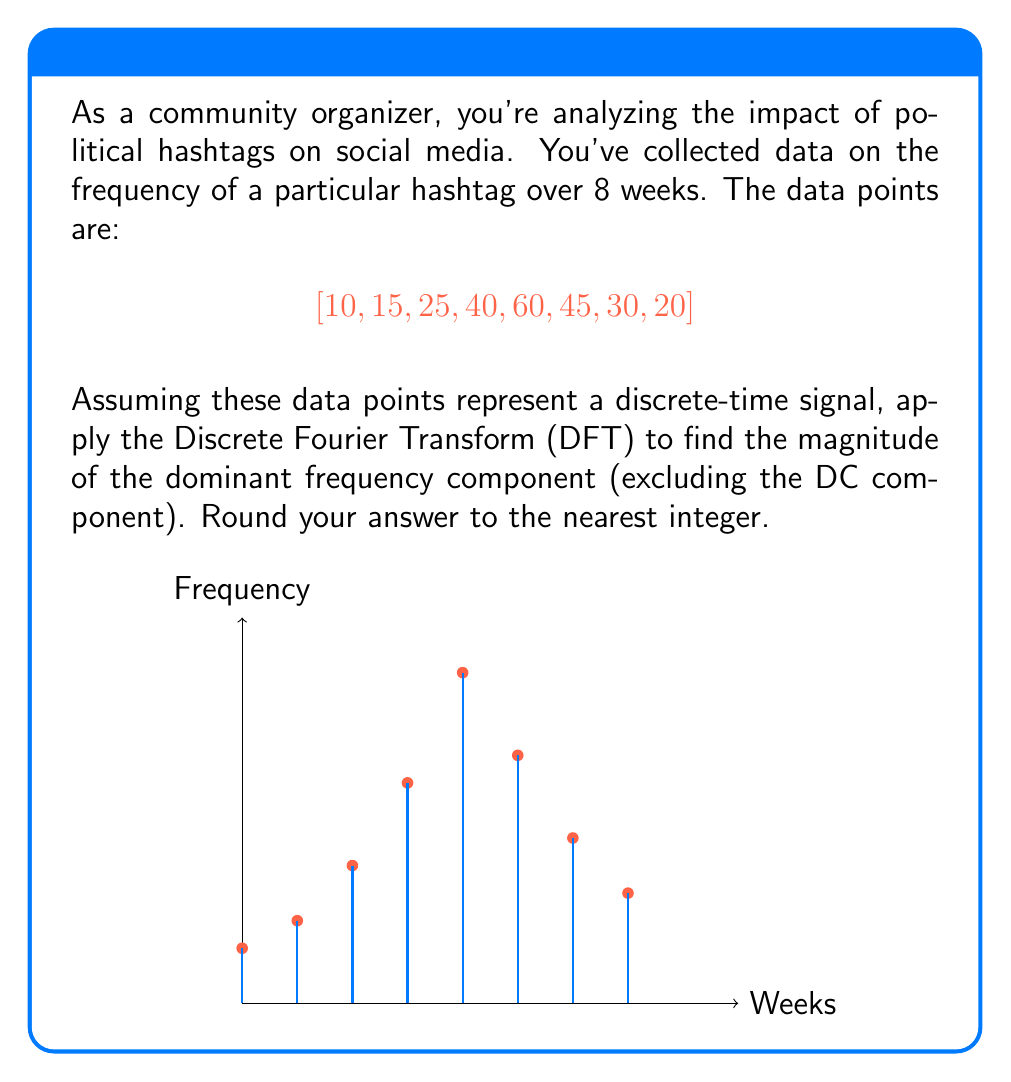Give your solution to this math problem. To solve this problem, we'll follow these steps:

1) The Discrete Fourier Transform (DFT) of a signal $x[n]$ of length $N$ is given by:

   $$X[k] = \sum_{n=0}^{N-1} x[n] e^{-j2\pi kn/N}$$

   where $k = 0, 1, ..., N-1$

2) In our case, $N = 8$ and $x[n] = [10, 15, 25, 40, 60, 45, 30, 20]$

3) We need to calculate $X[k]$ for $k = 0, 1, ..., 7$. Let's use a programming language or calculator for this computation.

4) After computation, we get:

   $$X = [245, 21.21-58.41i, -35+5i, -1.21+8.41i, 5, -1.21-8.41i, -35-5i, 21.21+58.41i]$$

5) The magnitude of each component is given by $|X[k]| = \sqrt{\text{Re}(X[k])^2 + \text{Im}(X[k])^2}$

6) Calculating the magnitudes:

   $$|X| = [245, 62.13, 35.36, 8.50, 5, 8.50, 35.36, 62.13]$$

7) The DC component is $X[0] = 245$. Excluding this, the largest magnitude is 62.13.

8) Rounding to the nearest integer gives us 62.
Answer: 62 